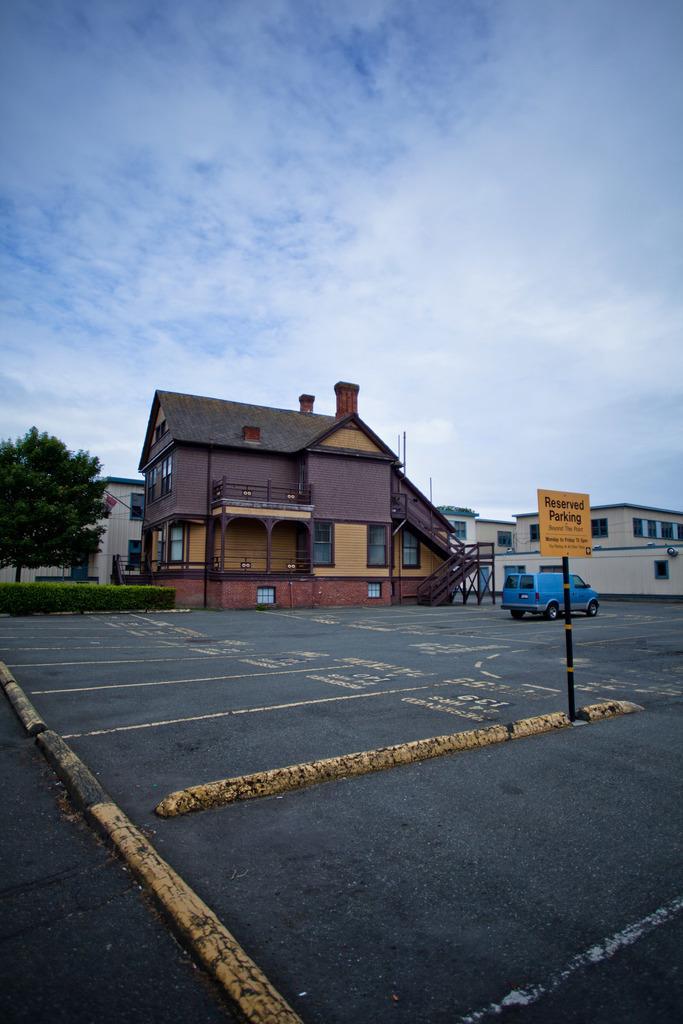Describe this image in one or two sentences. In the image there is road in the front with a vehicle going on it and behind there are homes with a tree on the left side and above its sky with clouds. 